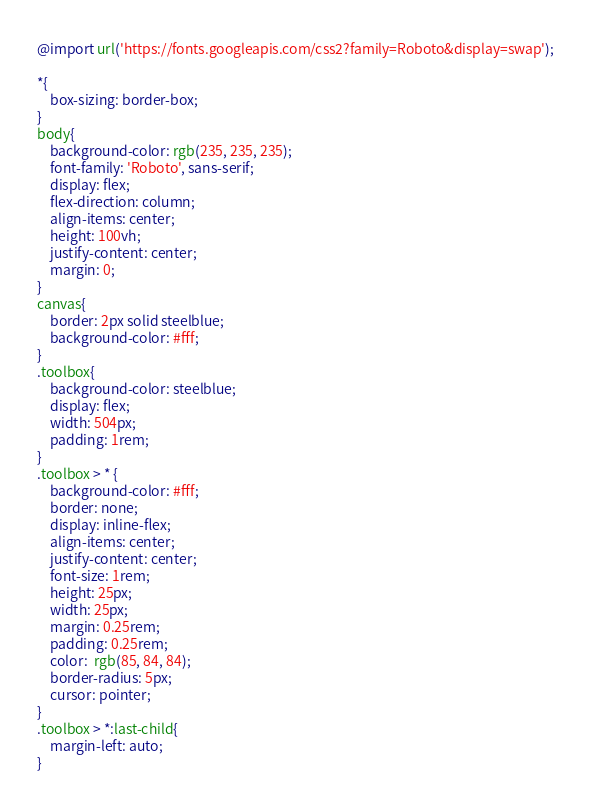Convert code to text. <code><loc_0><loc_0><loc_500><loc_500><_CSS_>@import url('https://fonts.googleapis.com/css2?family=Roboto&display=swap');

*{
    box-sizing: border-box;
}
body{
    background-color: rgb(235, 235, 235);
    font-family: 'Roboto', sans-serif;
    display: flex; 
    flex-direction: column; 
    align-items: center; 
    height: 100vh;
    justify-content: center; 
    margin: 0; 
}
canvas{
    border: 2px solid steelblue;
    background-color: #fff;
}
.toolbox{
    background-color: steelblue;
    display: flex;
    width: 504px;
    padding: 1rem;
}
.toolbox > * {
    background-color: #fff;
    border: none;
    display: inline-flex;
    align-items: center;
    justify-content: center;
    font-size: 1rem;
    height: 25px;
    width: 25px;
    margin: 0.25rem;
    padding: 0.25rem;
    color:  rgb(85, 84, 84);
    border-radius: 5px;
    cursor: pointer;
}
.toolbox > *:last-child{
    margin-left: auto;
}</code> 